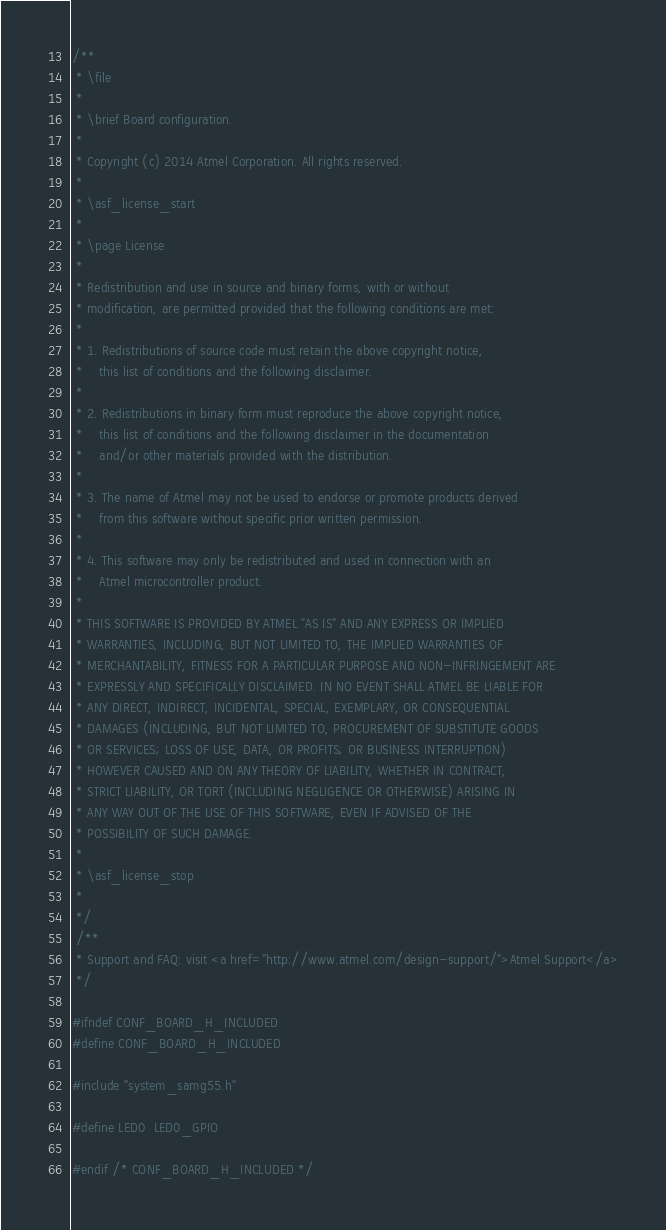Convert code to text. <code><loc_0><loc_0><loc_500><loc_500><_C_>/**
 * \file
 *
 * \brief Board configuration.
 *
 * Copyright (c) 2014 Atmel Corporation. All rights reserved.
 *
 * \asf_license_start
 *
 * \page License
 *
 * Redistribution and use in source and binary forms, with or without
 * modification, are permitted provided that the following conditions are met:
 *
 * 1. Redistributions of source code must retain the above copyright notice,
 *    this list of conditions and the following disclaimer.
 *
 * 2. Redistributions in binary form must reproduce the above copyright notice,
 *    this list of conditions and the following disclaimer in the documentation
 *    and/or other materials provided with the distribution.
 *
 * 3. The name of Atmel may not be used to endorse or promote products derived
 *    from this software without specific prior written permission.
 *
 * 4. This software may only be redistributed and used in connection with an
 *    Atmel microcontroller product.
 *
 * THIS SOFTWARE IS PROVIDED BY ATMEL "AS IS" AND ANY EXPRESS OR IMPLIED
 * WARRANTIES, INCLUDING, BUT NOT LIMITED TO, THE IMPLIED WARRANTIES OF
 * MERCHANTABILITY, FITNESS FOR A PARTICULAR PURPOSE AND NON-INFRINGEMENT ARE
 * EXPRESSLY AND SPECIFICALLY DISCLAIMED. IN NO EVENT SHALL ATMEL BE LIABLE FOR
 * ANY DIRECT, INDIRECT, INCIDENTAL, SPECIAL, EXEMPLARY, OR CONSEQUENTIAL
 * DAMAGES (INCLUDING, BUT NOT LIMITED TO, PROCUREMENT OF SUBSTITUTE GOODS
 * OR SERVICES; LOSS OF USE, DATA, OR PROFITS; OR BUSINESS INTERRUPTION)
 * HOWEVER CAUSED AND ON ANY THEORY OF LIABILITY, WHETHER IN CONTRACT,
 * STRICT LIABILITY, OR TORT (INCLUDING NEGLIGENCE OR OTHERWISE) ARISING IN
 * ANY WAY OUT OF THE USE OF THIS SOFTWARE, EVEN IF ADVISED OF THE
 * POSSIBILITY OF SUCH DAMAGE.
 *
 * \asf_license_stop
 *
 */
 /**
 * Support and FAQ: visit <a href="http://www.atmel.com/design-support/">Atmel Support</a>
 */

#ifndef CONF_BOARD_H_INCLUDED
#define CONF_BOARD_H_INCLUDED

#include "system_samg55.h"

#define LED0  LED0_GPIO

#endif /* CONF_BOARD_H_INCLUDED */
</code> 